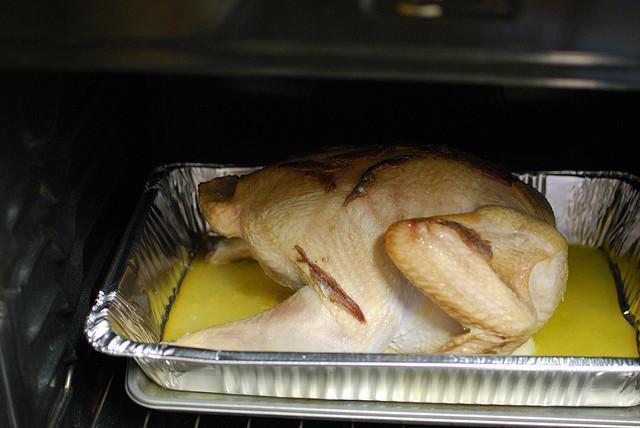Is the statement "The oven contains the bird." accurate regarding the image?
Answer yes or no. Yes. Does the image validate the caption "The bird is next to the oven."?
Answer yes or no. No. Evaluate: Does the caption "The bird is touching the oven." match the image?
Answer yes or no. No. Does the image validate the caption "The oven is surrounding the bird."?
Answer yes or no. Yes. 